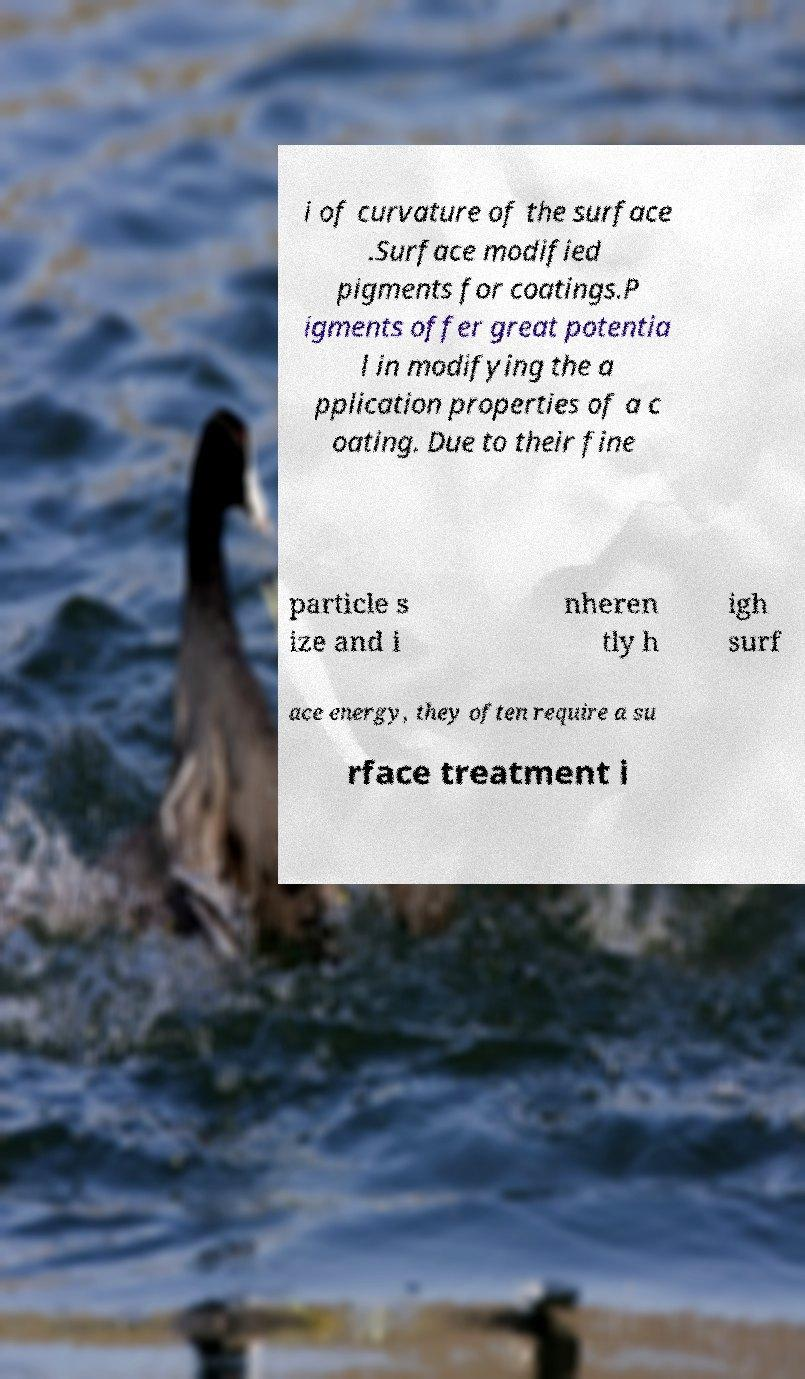Can you accurately transcribe the text from the provided image for me? i of curvature of the surface .Surface modified pigments for coatings.P igments offer great potentia l in modifying the a pplication properties of a c oating. Due to their fine particle s ize and i nheren tly h igh surf ace energy, they often require a su rface treatment i 